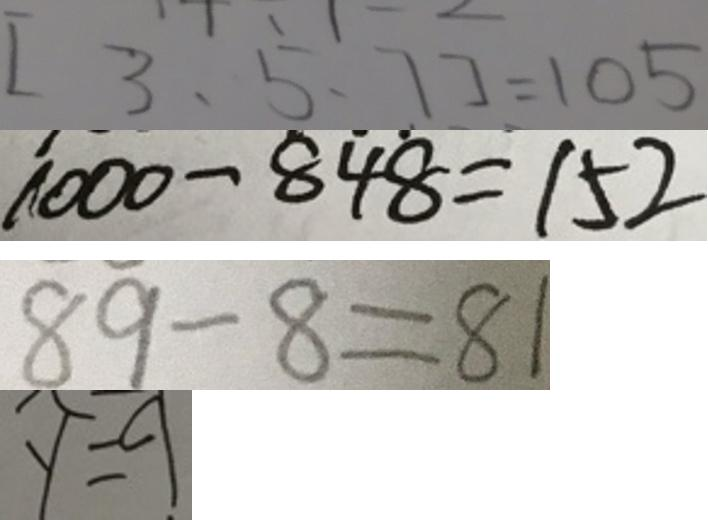<formula> <loc_0><loc_0><loc_500><loc_500>[ 3 , 5 , 7 ] = 1 0 5 
 1 0 0 0 - 8 \dot { 4 } \dot { 8 } = 1 5 2 
 8 9 - 8 = 8 1 
 y = 9</formula> 